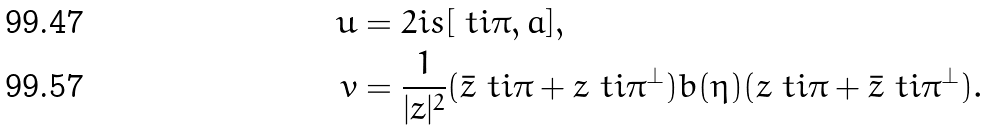<formula> <loc_0><loc_0><loc_500><loc_500>u & = 2 i s [ \ t i \pi , a ] , \\ v & = \frac { 1 } { | z | ^ { 2 } } ( \bar { z } \ t i \pi + z \ t i \pi ^ { \perp } ) b ( \eta ) ( z \ t i \pi + \bar { z } \ t i \pi ^ { \perp } ) .</formula> 